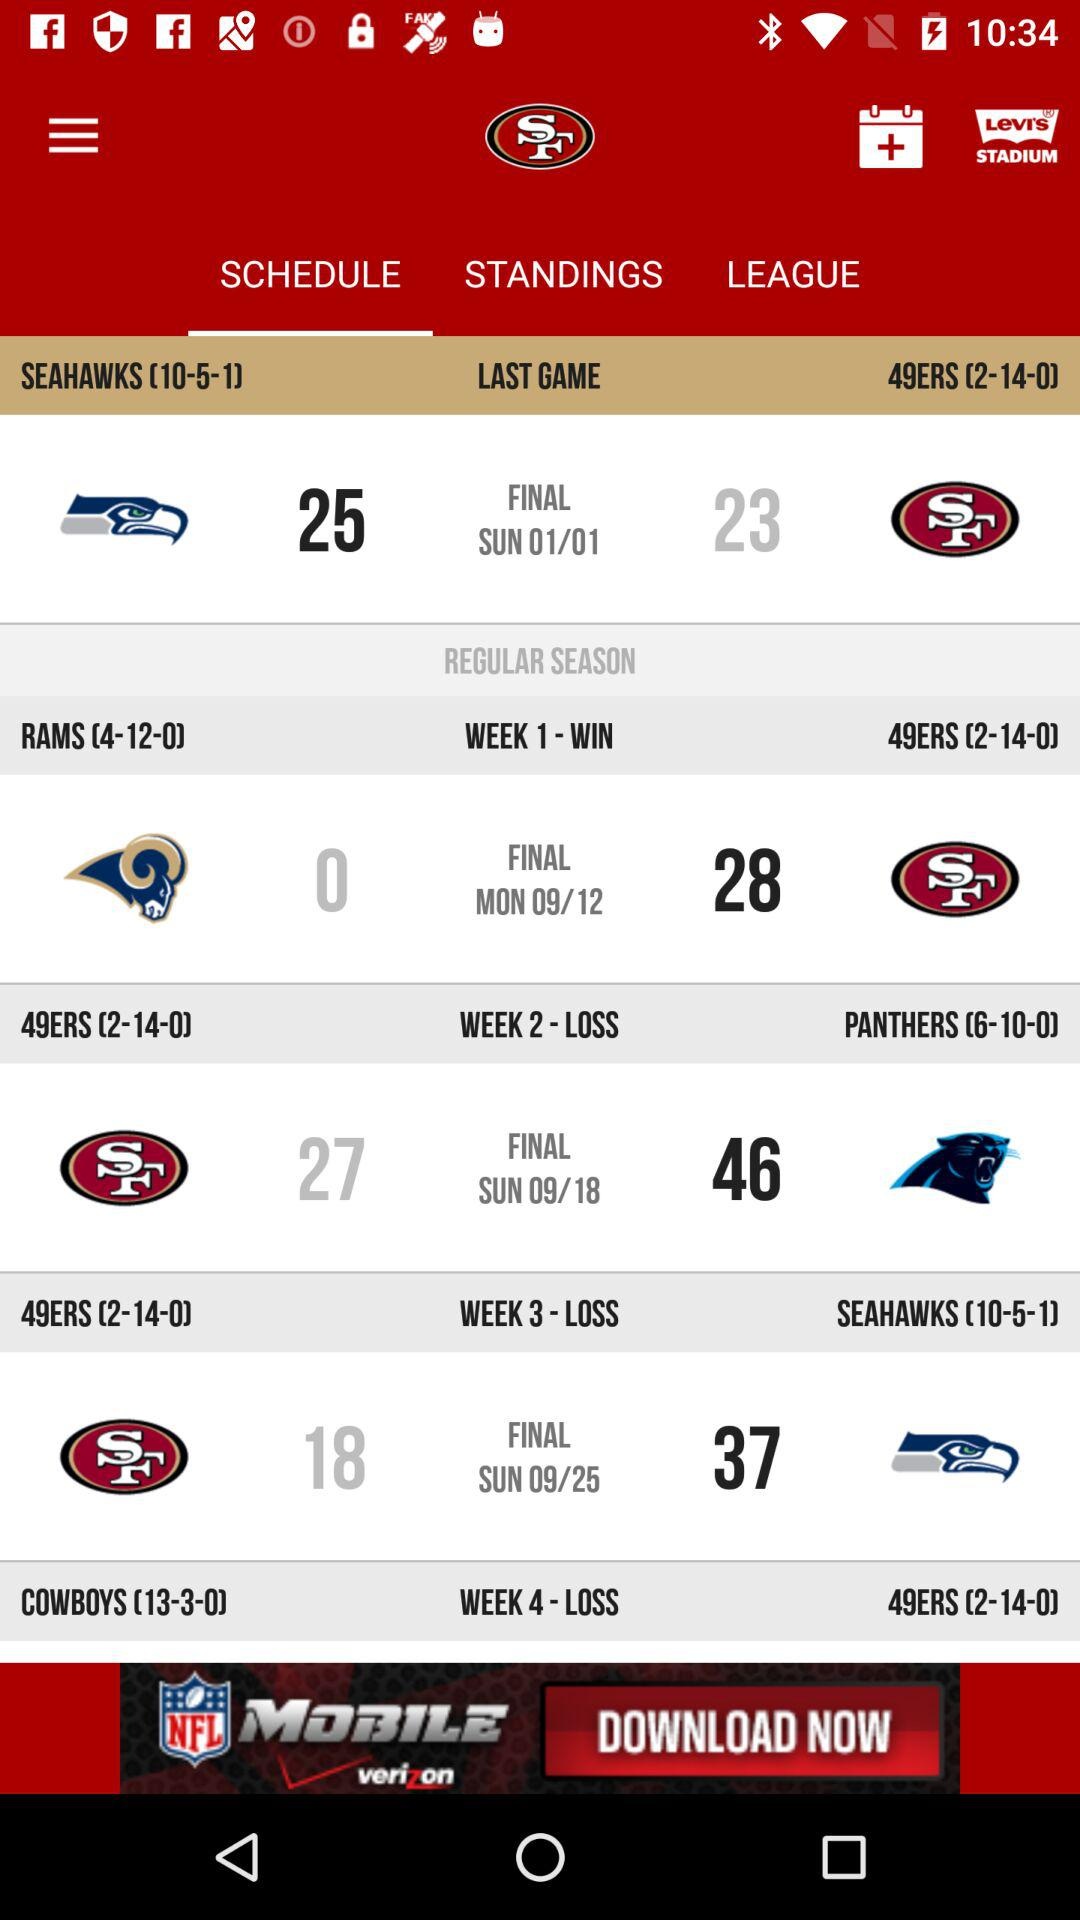What was the result of the match played in week 2? The result of the match played in week 2 was a loss. 